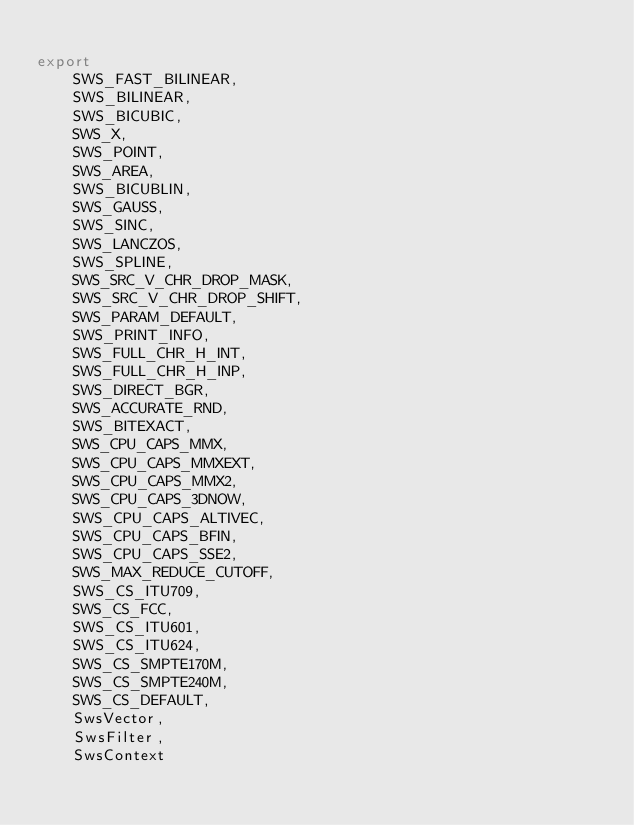Convert code to text. <code><loc_0><loc_0><loc_500><loc_500><_Julia_>
export
    SWS_FAST_BILINEAR,
    SWS_BILINEAR,
    SWS_BICUBIC,
    SWS_X,
    SWS_POINT,
    SWS_AREA,
    SWS_BICUBLIN,
    SWS_GAUSS,
    SWS_SINC,
    SWS_LANCZOS,
    SWS_SPLINE,
    SWS_SRC_V_CHR_DROP_MASK,
    SWS_SRC_V_CHR_DROP_SHIFT,
    SWS_PARAM_DEFAULT,
    SWS_PRINT_INFO,
    SWS_FULL_CHR_H_INT,
    SWS_FULL_CHR_H_INP,
    SWS_DIRECT_BGR,
    SWS_ACCURATE_RND,
    SWS_BITEXACT,
    SWS_CPU_CAPS_MMX,
    SWS_CPU_CAPS_MMXEXT,
    SWS_CPU_CAPS_MMX2,
    SWS_CPU_CAPS_3DNOW,
    SWS_CPU_CAPS_ALTIVEC,
    SWS_CPU_CAPS_BFIN,
    SWS_CPU_CAPS_SSE2,
    SWS_MAX_REDUCE_CUTOFF,
    SWS_CS_ITU709,
    SWS_CS_FCC,
    SWS_CS_ITU601,
    SWS_CS_ITU624,
    SWS_CS_SMPTE170M,
    SWS_CS_SMPTE240M,
    SWS_CS_DEFAULT,
    SwsVector,
    SwsFilter,
    SwsContext

</code> 